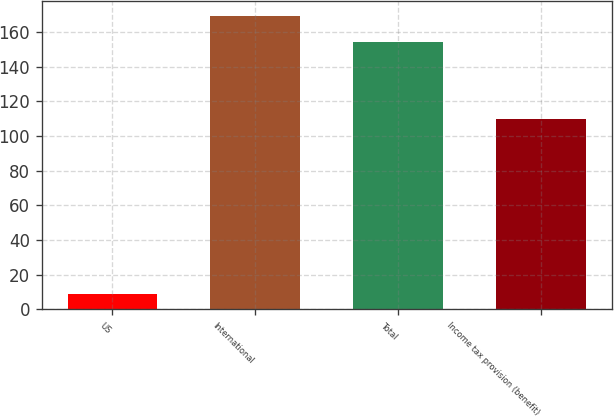<chart> <loc_0><loc_0><loc_500><loc_500><bar_chart><fcel>US<fcel>International<fcel>Total<fcel>Income tax provision (benefit)<nl><fcel>9<fcel>169.4<fcel>154<fcel>110<nl></chart> 